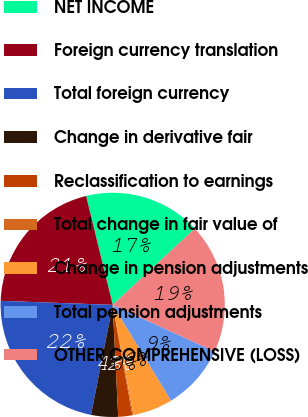Convert chart. <chart><loc_0><loc_0><loc_500><loc_500><pie_chart><fcel>NET INCOME<fcel>Foreign currency translation<fcel>Total foreign currency<fcel>Change in derivative fair<fcel>Reclassification to earnings<fcel>Total change in fair value of<fcel>Change in pension adjustments<fcel>Total pension adjustments<fcel>OTHER COMPREHENSIVE (LOSS)<nl><fcel>16.89%<fcel>20.61%<fcel>22.47%<fcel>3.88%<fcel>2.02%<fcel>0.17%<fcel>5.74%<fcel>9.46%<fcel>18.75%<nl></chart> 